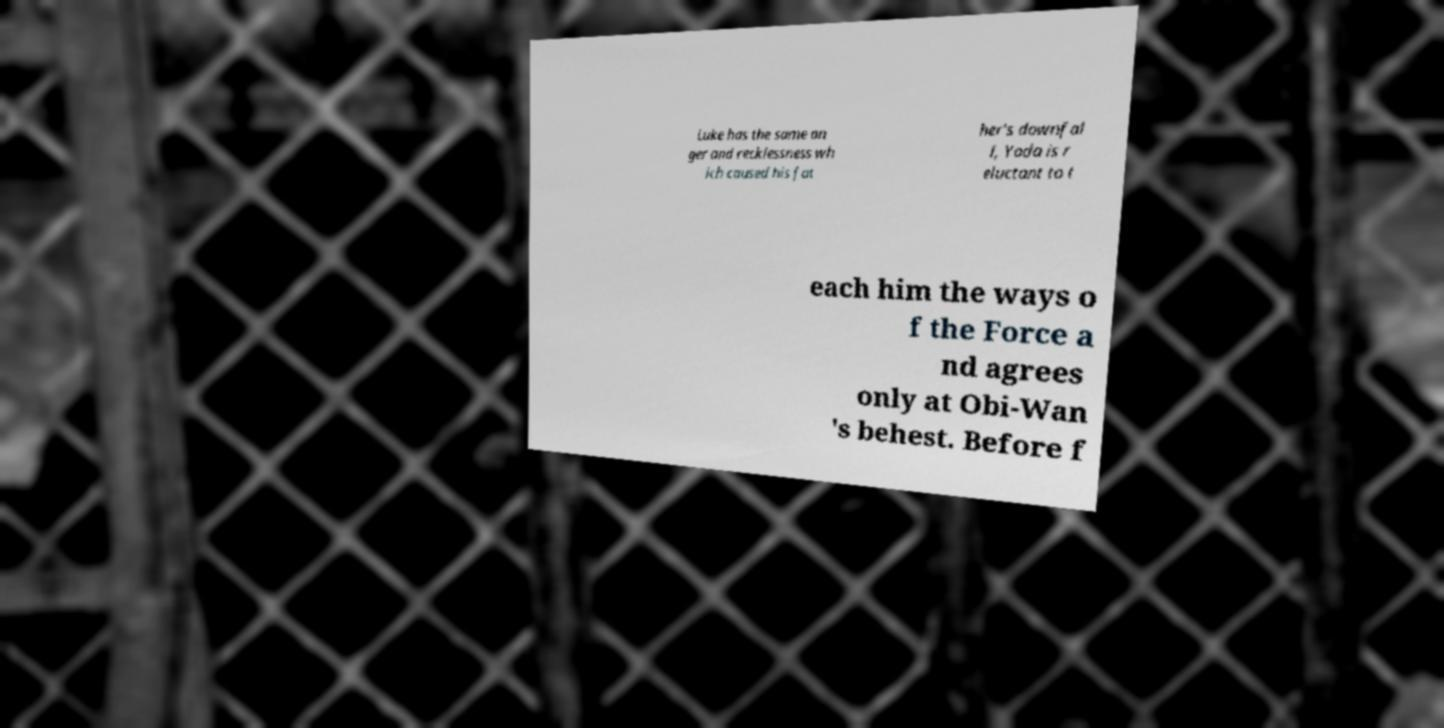I need the written content from this picture converted into text. Can you do that? Luke has the same an ger and recklessness wh ich caused his fat her's downfal l, Yoda is r eluctant to t each him the ways o f the Force a nd agrees only at Obi-Wan 's behest. Before f 